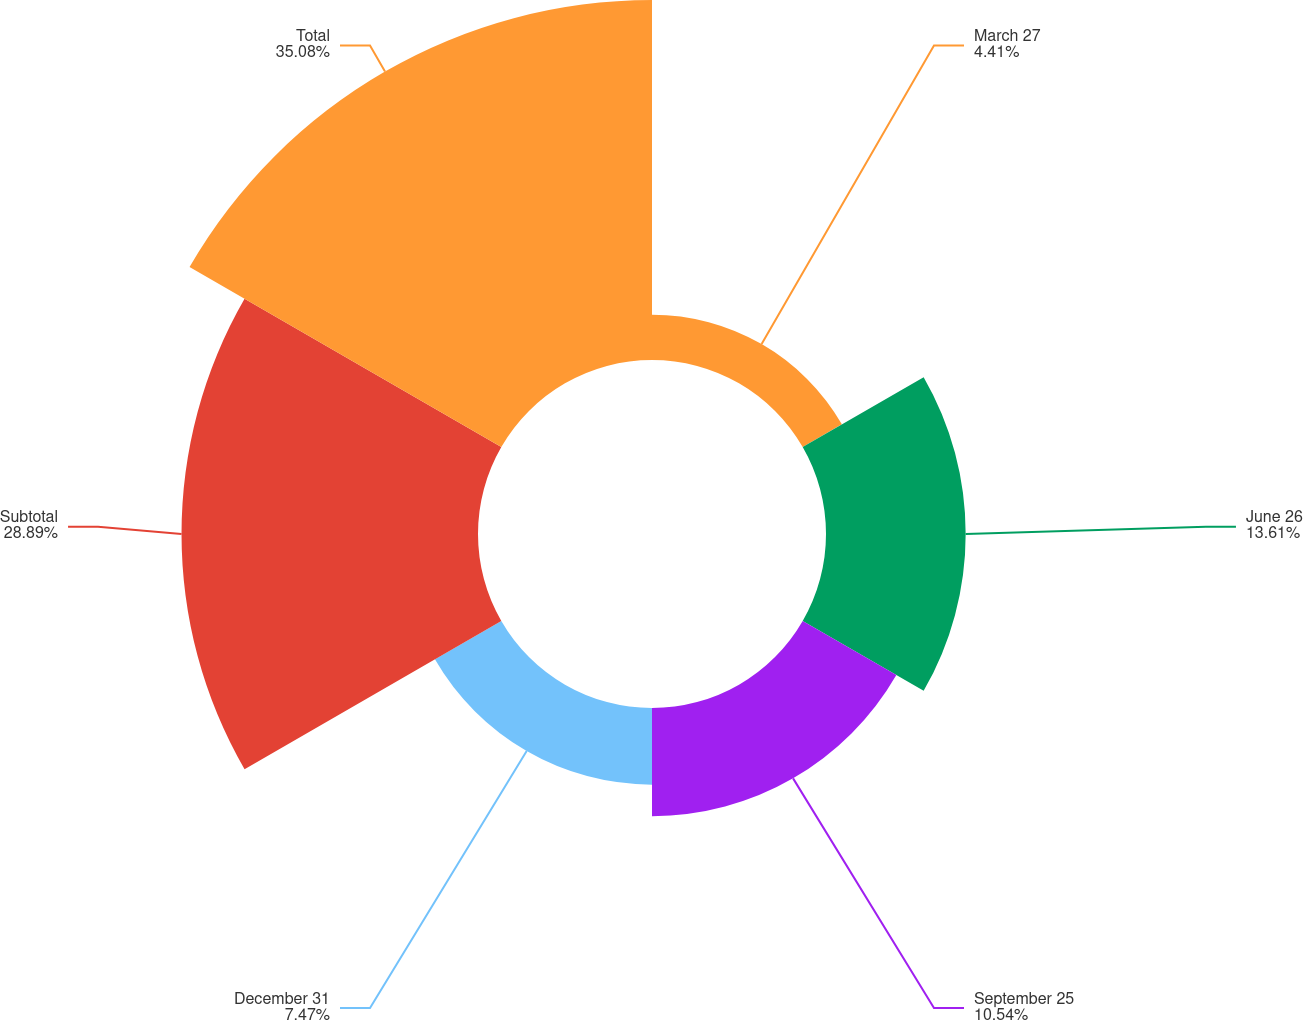Convert chart to OTSL. <chart><loc_0><loc_0><loc_500><loc_500><pie_chart><fcel>March 27<fcel>June 26<fcel>September 25<fcel>December 31<fcel>Subtotal<fcel>Total<nl><fcel>4.41%<fcel>13.61%<fcel>10.54%<fcel>7.47%<fcel>28.89%<fcel>35.08%<nl></chart> 